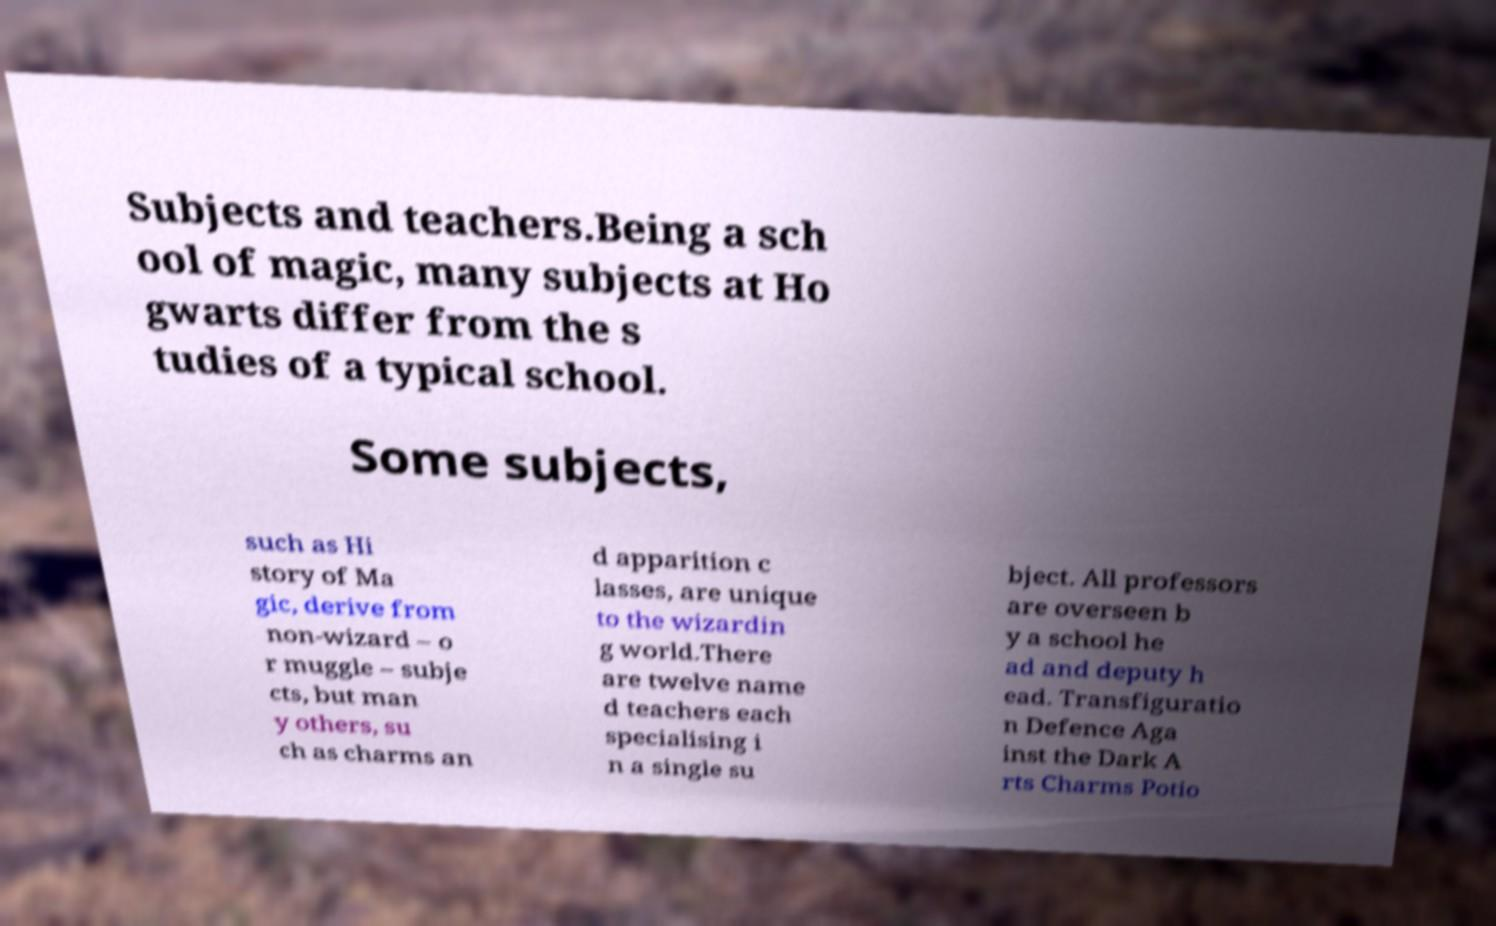Can you accurately transcribe the text from the provided image for me? Subjects and teachers.Being a sch ool of magic, many subjects at Ho gwarts differ from the s tudies of a typical school. Some subjects, such as Hi story of Ma gic, derive from non-wizard – o r muggle – subje cts, but man y others, su ch as charms an d apparition c lasses, are unique to the wizardin g world.There are twelve name d teachers each specialising i n a single su bject. All professors are overseen b y a school he ad and deputy h ead. Transfiguratio n Defence Aga inst the Dark A rts Charms Potio 